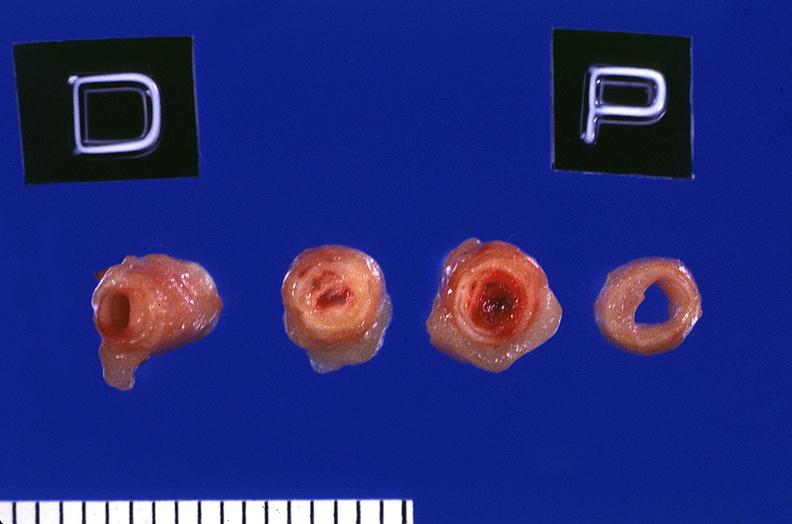where is this?
Answer the question using a single word or phrase. Vasculature 